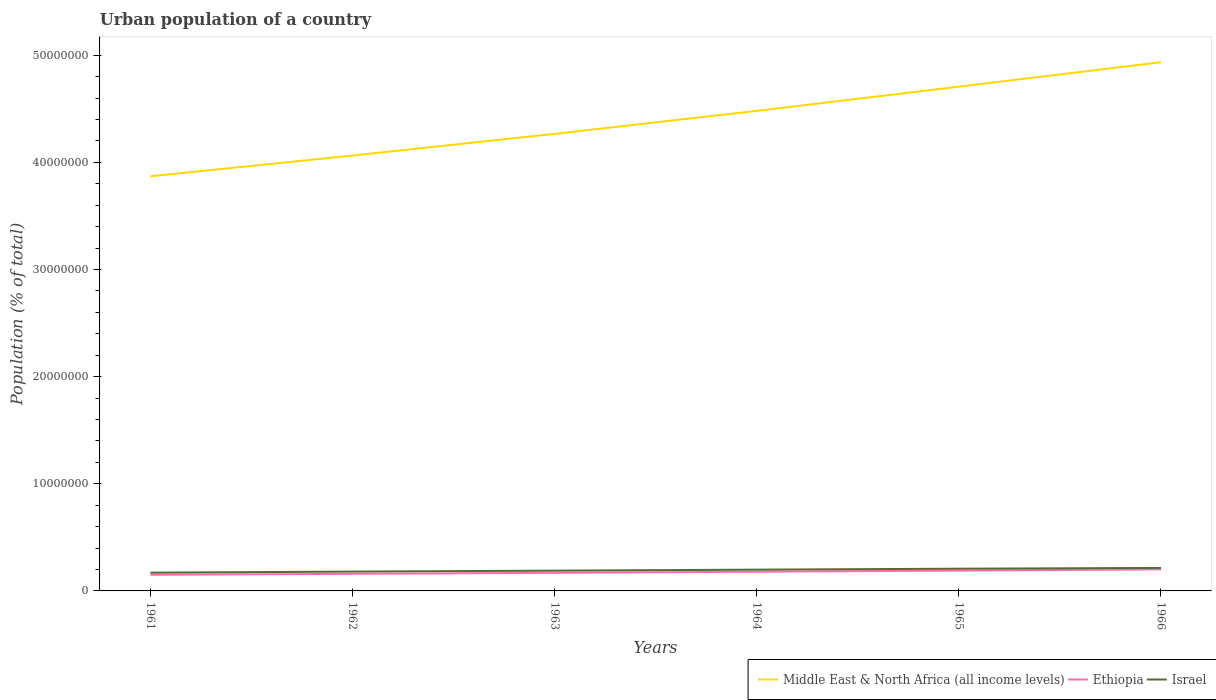How many different coloured lines are there?
Provide a short and direct response. 3. Does the line corresponding to Ethiopia intersect with the line corresponding to Middle East & North Africa (all income levels)?
Make the answer very short. No. Across all years, what is the maximum urban population in Israel?
Provide a short and direct response. 1.70e+06. What is the total urban population in Ethiopia in the graph?
Your answer should be very brief. -8.86e+04. What is the difference between the highest and the second highest urban population in Middle East & North Africa (all income levels)?
Provide a succinct answer. 1.07e+07. Are the values on the major ticks of Y-axis written in scientific E-notation?
Offer a very short reply. No. Does the graph contain any zero values?
Ensure brevity in your answer.  No. Does the graph contain grids?
Offer a very short reply. No. Where does the legend appear in the graph?
Your response must be concise. Bottom right. How many legend labels are there?
Your answer should be compact. 3. What is the title of the graph?
Make the answer very short. Urban population of a country. What is the label or title of the Y-axis?
Give a very brief answer. Population (% of total). What is the Population (% of total) in Middle East & North Africa (all income levels) in 1961?
Offer a very short reply. 3.87e+07. What is the Population (% of total) in Ethiopia in 1961?
Offer a terse response. 1.51e+06. What is the Population (% of total) in Israel in 1961?
Give a very brief answer. 1.70e+06. What is the Population (% of total) in Middle East & North Africa (all income levels) in 1962?
Provide a short and direct response. 4.06e+07. What is the Population (% of total) in Ethiopia in 1962?
Provide a short and direct response. 1.60e+06. What is the Population (% of total) in Israel in 1962?
Provide a short and direct response. 1.81e+06. What is the Population (% of total) of Middle East & North Africa (all income levels) in 1963?
Make the answer very short. 4.27e+07. What is the Population (% of total) in Ethiopia in 1963?
Keep it short and to the point. 1.69e+06. What is the Population (% of total) in Israel in 1963?
Provide a succinct answer. 1.89e+06. What is the Population (% of total) of Middle East & North Africa (all income levels) in 1964?
Give a very brief answer. 4.48e+07. What is the Population (% of total) in Ethiopia in 1964?
Ensure brevity in your answer.  1.79e+06. What is the Population (% of total) in Israel in 1964?
Offer a very short reply. 1.99e+06. What is the Population (% of total) in Middle East & North Africa (all income levels) in 1965?
Keep it short and to the point. 4.71e+07. What is the Population (% of total) in Ethiopia in 1965?
Keep it short and to the point. 1.90e+06. What is the Population (% of total) of Israel in 1965?
Offer a very short reply. 2.07e+06. What is the Population (% of total) of Middle East & North Africa (all income levels) in 1966?
Your answer should be compact. 4.94e+07. What is the Population (% of total) of Ethiopia in 1966?
Provide a succinct answer. 2.01e+06. What is the Population (% of total) of Israel in 1966?
Ensure brevity in your answer.  2.15e+06. Across all years, what is the maximum Population (% of total) of Middle East & North Africa (all income levels)?
Give a very brief answer. 4.94e+07. Across all years, what is the maximum Population (% of total) in Ethiopia?
Ensure brevity in your answer.  2.01e+06. Across all years, what is the maximum Population (% of total) of Israel?
Your response must be concise. 2.15e+06. Across all years, what is the minimum Population (% of total) in Middle East & North Africa (all income levels)?
Provide a succinct answer. 3.87e+07. Across all years, what is the minimum Population (% of total) in Ethiopia?
Make the answer very short. 1.51e+06. Across all years, what is the minimum Population (% of total) in Israel?
Give a very brief answer. 1.70e+06. What is the total Population (% of total) in Middle East & North Africa (all income levels) in the graph?
Your response must be concise. 2.63e+08. What is the total Population (% of total) in Ethiopia in the graph?
Your response must be concise. 1.05e+07. What is the total Population (% of total) of Israel in the graph?
Ensure brevity in your answer.  1.16e+07. What is the difference between the Population (% of total) in Middle East & North Africa (all income levels) in 1961 and that in 1962?
Provide a succinct answer. -1.94e+06. What is the difference between the Population (% of total) in Ethiopia in 1961 and that in 1962?
Your answer should be very brief. -8.86e+04. What is the difference between the Population (% of total) in Israel in 1961 and that in 1962?
Provide a short and direct response. -1.02e+05. What is the difference between the Population (% of total) in Middle East & North Africa (all income levels) in 1961 and that in 1963?
Offer a very short reply. -3.96e+06. What is the difference between the Population (% of total) of Ethiopia in 1961 and that in 1963?
Your response must be concise. -1.83e+05. What is the difference between the Population (% of total) of Israel in 1961 and that in 1963?
Offer a terse response. -1.87e+05. What is the difference between the Population (% of total) in Middle East & North Africa (all income levels) in 1961 and that in 1964?
Ensure brevity in your answer.  -6.11e+06. What is the difference between the Population (% of total) of Ethiopia in 1961 and that in 1964?
Your response must be concise. -2.84e+05. What is the difference between the Population (% of total) in Israel in 1961 and that in 1964?
Your response must be concise. -2.82e+05. What is the difference between the Population (% of total) of Middle East & North Africa (all income levels) in 1961 and that in 1965?
Provide a succinct answer. -8.37e+06. What is the difference between the Population (% of total) in Ethiopia in 1961 and that in 1965?
Ensure brevity in your answer.  -3.90e+05. What is the difference between the Population (% of total) of Israel in 1961 and that in 1965?
Provide a short and direct response. -3.71e+05. What is the difference between the Population (% of total) in Middle East & North Africa (all income levels) in 1961 and that in 1966?
Your response must be concise. -1.07e+07. What is the difference between the Population (% of total) of Ethiopia in 1961 and that in 1966?
Your answer should be very brief. -5.03e+05. What is the difference between the Population (% of total) of Israel in 1961 and that in 1966?
Ensure brevity in your answer.  -4.42e+05. What is the difference between the Population (% of total) in Middle East & North Africa (all income levels) in 1962 and that in 1963?
Your response must be concise. -2.03e+06. What is the difference between the Population (% of total) in Ethiopia in 1962 and that in 1963?
Your answer should be compact. -9.44e+04. What is the difference between the Population (% of total) of Israel in 1962 and that in 1963?
Provide a short and direct response. -8.55e+04. What is the difference between the Population (% of total) in Middle East & North Africa (all income levels) in 1962 and that in 1964?
Keep it short and to the point. -4.17e+06. What is the difference between the Population (% of total) in Ethiopia in 1962 and that in 1964?
Offer a terse response. -1.95e+05. What is the difference between the Population (% of total) of Israel in 1962 and that in 1964?
Your answer should be very brief. -1.80e+05. What is the difference between the Population (% of total) of Middle East & North Africa (all income levels) in 1962 and that in 1965?
Make the answer very short. -6.43e+06. What is the difference between the Population (% of total) in Ethiopia in 1962 and that in 1965?
Your answer should be very brief. -3.02e+05. What is the difference between the Population (% of total) in Israel in 1962 and that in 1965?
Ensure brevity in your answer.  -2.69e+05. What is the difference between the Population (% of total) in Middle East & North Africa (all income levels) in 1962 and that in 1966?
Ensure brevity in your answer.  -8.71e+06. What is the difference between the Population (% of total) in Ethiopia in 1962 and that in 1966?
Provide a succinct answer. -4.14e+05. What is the difference between the Population (% of total) of Israel in 1962 and that in 1966?
Offer a terse response. -3.40e+05. What is the difference between the Population (% of total) in Middle East & North Africa (all income levels) in 1963 and that in 1964?
Offer a terse response. -2.14e+06. What is the difference between the Population (% of total) of Ethiopia in 1963 and that in 1964?
Your answer should be very brief. -1.01e+05. What is the difference between the Population (% of total) in Israel in 1963 and that in 1964?
Offer a terse response. -9.44e+04. What is the difference between the Population (% of total) of Middle East & North Africa (all income levels) in 1963 and that in 1965?
Your response must be concise. -4.41e+06. What is the difference between the Population (% of total) of Ethiopia in 1963 and that in 1965?
Your answer should be very brief. -2.07e+05. What is the difference between the Population (% of total) in Israel in 1963 and that in 1965?
Provide a succinct answer. -1.83e+05. What is the difference between the Population (% of total) of Middle East & North Africa (all income levels) in 1963 and that in 1966?
Offer a terse response. -6.69e+06. What is the difference between the Population (% of total) of Ethiopia in 1963 and that in 1966?
Provide a succinct answer. -3.20e+05. What is the difference between the Population (% of total) in Israel in 1963 and that in 1966?
Offer a very short reply. -2.55e+05. What is the difference between the Population (% of total) in Middle East & North Africa (all income levels) in 1964 and that in 1965?
Ensure brevity in your answer.  -2.26e+06. What is the difference between the Population (% of total) in Ethiopia in 1964 and that in 1965?
Offer a terse response. -1.07e+05. What is the difference between the Population (% of total) of Israel in 1964 and that in 1965?
Make the answer very short. -8.88e+04. What is the difference between the Population (% of total) in Middle East & North Africa (all income levels) in 1964 and that in 1966?
Provide a succinct answer. -4.54e+06. What is the difference between the Population (% of total) in Ethiopia in 1964 and that in 1966?
Your response must be concise. -2.19e+05. What is the difference between the Population (% of total) in Israel in 1964 and that in 1966?
Your answer should be compact. -1.60e+05. What is the difference between the Population (% of total) of Middle East & North Africa (all income levels) in 1965 and that in 1966?
Provide a short and direct response. -2.28e+06. What is the difference between the Population (% of total) of Ethiopia in 1965 and that in 1966?
Make the answer very short. -1.12e+05. What is the difference between the Population (% of total) in Israel in 1965 and that in 1966?
Give a very brief answer. -7.16e+04. What is the difference between the Population (% of total) in Middle East & North Africa (all income levels) in 1961 and the Population (% of total) in Ethiopia in 1962?
Offer a very short reply. 3.71e+07. What is the difference between the Population (% of total) of Middle East & North Africa (all income levels) in 1961 and the Population (% of total) of Israel in 1962?
Offer a very short reply. 3.69e+07. What is the difference between the Population (% of total) of Ethiopia in 1961 and the Population (% of total) of Israel in 1962?
Your answer should be very brief. -2.98e+05. What is the difference between the Population (% of total) in Middle East & North Africa (all income levels) in 1961 and the Population (% of total) in Ethiopia in 1963?
Make the answer very short. 3.70e+07. What is the difference between the Population (% of total) of Middle East & North Africa (all income levels) in 1961 and the Population (% of total) of Israel in 1963?
Keep it short and to the point. 3.68e+07. What is the difference between the Population (% of total) in Ethiopia in 1961 and the Population (% of total) in Israel in 1963?
Provide a short and direct response. -3.84e+05. What is the difference between the Population (% of total) of Middle East & North Africa (all income levels) in 1961 and the Population (% of total) of Ethiopia in 1964?
Ensure brevity in your answer.  3.69e+07. What is the difference between the Population (% of total) of Middle East & North Africa (all income levels) in 1961 and the Population (% of total) of Israel in 1964?
Provide a succinct answer. 3.67e+07. What is the difference between the Population (% of total) of Ethiopia in 1961 and the Population (% of total) of Israel in 1964?
Provide a succinct answer. -4.78e+05. What is the difference between the Population (% of total) in Middle East & North Africa (all income levels) in 1961 and the Population (% of total) in Ethiopia in 1965?
Ensure brevity in your answer.  3.68e+07. What is the difference between the Population (% of total) of Middle East & North Africa (all income levels) in 1961 and the Population (% of total) of Israel in 1965?
Provide a succinct answer. 3.66e+07. What is the difference between the Population (% of total) of Ethiopia in 1961 and the Population (% of total) of Israel in 1965?
Your answer should be compact. -5.67e+05. What is the difference between the Population (% of total) of Middle East & North Africa (all income levels) in 1961 and the Population (% of total) of Ethiopia in 1966?
Provide a short and direct response. 3.67e+07. What is the difference between the Population (% of total) of Middle East & North Africa (all income levels) in 1961 and the Population (% of total) of Israel in 1966?
Make the answer very short. 3.66e+07. What is the difference between the Population (% of total) in Ethiopia in 1961 and the Population (% of total) in Israel in 1966?
Your response must be concise. -6.38e+05. What is the difference between the Population (% of total) in Middle East & North Africa (all income levels) in 1962 and the Population (% of total) in Ethiopia in 1963?
Your response must be concise. 3.90e+07. What is the difference between the Population (% of total) in Middle East & North Africa (all income levels) in 1962 and the Population (% of total) in Israel in 1963?
Provide a succinct answer. 3.88e+07. What is the difference between the Population (% of total) of Ethiopia in 1962 and the Population (% of total) of Israel in 1963?
Ensure brevity in your answer.  -2.95e+05. What is the difference between the Population (% of total) of Middle East & North Africa (all income levels) in 1962 and the Population (% of total) of Ethiopia in 1964?
Provide a short and direct response. 3.89e+07. What is the difference between the Population (% of total) in Middle East & North Africa (all income levels) in 1962 and the Population (% of total) in Israel in 1964?
Offer a terse response. 3.87e+07. What is the difference between the Population (% of total) of Ethiopia in 1962 and the Population (% of total) of Israel in 1964?
Make the answer very short. -3.90e+05. What is the difference between the Population (% of total) in Middle East & North Africa (all income levels) in 1962 and the Population (% of total) in Ethiopia in 1965?
Your response must be concise. 3.87e+07. What is the difference between the Population (% of total) of Middle East & North Africa (all income levels) in 1962 and the Population (% of total) of Israel in 1965?
Keep it short and to the point. 3.86e+07. What is the difference between the Population (% of total) in Ethiopia in 1962 and the Population (% of total) in Israel in 1965?
Offer a very short reply. -4.78e+05. What is the difference between the Population (% of total) of Middle East & North Africa (all income levels) in 1962 and the Population (% of total) of Ethiopia in 1966?
Your answer should be compact. 3.86e+07. What is the difference between the Population (% of total) in Middle East & North Africa (all income levels) in 1962 and the Population (% of total) in Israel in 1966?
Make the answer very short. 3.85e+07. What is the difference between the Population (% of total) of Ethiopia in 1962 and the Population (% of total) of Israel in 1966?
Your answer should be very brief. -5.50e+05. What is the difference between the Population (% of total) in Middle East & North Africa (all income levels) in 1963 and the Population (% of total) in Ethiopia in 1964?
Offer a terse response. 4.09e+07. What is the difference between the Population (% of total) of Middle East & North Africa (all income levels) in 1963 and the Population (% of total) of Israel in 1964?
Your answer should be compact. 4.07e+07. What is the difference between the Population (% of total) in Ethiopia in 1963 and the Population (% of total) in Israel in 1964?
Your answer should be compact. -2.95e+05. What is the difference between the Population (% of total) of Middle East & North Africa (all income levels) in 1963 and the Population (% of total) of Ethiopia in 1965?
Give a very brief answer. 4.08e+07. What is the difference between the Population (% of total) in Middle East & North Africa (all income levels) in 1963 and the Population (% of total) in Israel in 1965?
Ensure brevity in your answer.  4.06e+07. What is the difference between the Population (% of total) in Ethiopia in 1963 and the Population (% of total) in Israel in 1965?
Ensure brevity in your answer.  -3.84e+05. What is the difference between the Population (% of total) of Middle East & North Africa (all income levels) in 1963 and the Population (% of total) of Ethiopia in 1966?
Give a very brief answer. 4.07e+07. What is the difference between the Population (% of total) of Middle East & North Africa (all income levels) in 1963 and the Population (% of total) of Israel in 1966?
Keep it short and to the point. 4.05e+07. What is the difference between the Population (% of total) in Ethiopia in 1963 and the Population (% of total) in Israel in 1966?
Make the answer very short. -4.55e+05. What is the difference between the Population (% of total) of Middle East & North Africa (all income levels) in 1964 and the Population (% of total) of Ethiopia in 1965?
Your response must be concise. 4.29e+07. What is the difference between the Population (% of total) of Middle East & North Africa (all income levels) in 1964 and the Population (% of total) of Israel in 1965?
Offer a very short reply. 4.27e+07. What is the difference between the Population (% of total) in Ethiopia in 1964 and the Population (% of total) in Israel in 1965?
Make the answer very short. -2.83e+05. What is the difference between the Population (% of total) of Middle East & North Africa (all income levels) in 1964 and the Population (% of total) of Ethiopia in 1966?
Offer a terse response. 4.28e+07. What is the difference between the Population (% of total) of Middle East & North Africa (all income levels) in 1964 and the Population (% of total) of Israel in 1966?
Offer a very short reply. 4.27e+07. What is the difference between the Population (% of total) in Ethiopia in 1964 and the Population (% of total) in Israel in 1966?
Offer a terse response. -3.55e+05. What is the difference between the Population (% of total) of Middle East & North Africa (all income levels) in 1965 and the Population (% of total) of Ethiopia in 1966?
Ensure brevity in your answer.  4.51e+07. What is the difference between the Population (% of total) of Middle East & North Africa (all income levels) in 1965 and the Population (% of total) of Israel in 1966?
Your response must be concise. 4.49e+07. What is the difference between the Population (% of total) of Ethiopia in 1965 and the Population (% of total) of Israel in 1966?
Ensure brevity in your answer.  -2.48e+05. What is the average Population (% of total) in Middle East & North Africa (all income levels) per year?
Your response must be concise. 4.39e+07. What is the average Population (% of total) in Ethiopia per year?
Give a very brief answer. 1.75e+06. What is the average Population (% of total) in Israel per year?
Make the answer very short. 1.93e+06. In the year 1961, what is the difference between the Population (% of total) of Middle East & North Africa (all income levels) and Population (% of total) of Ethiopia?
Keep it short and to the point. 3.72e+07. In the year 1961, what is the difference between the Population (% of total) of Middle East & North Africa (all income levels) and Population (% of total) of Israel?
Your response must be concise. 3.70e+07. In the year 1961, what is the difference between the Population (% of total) in Ethiopia and Population (% of total) in Israel?
Your answer should be compact. -1.96e+05. In the year 1962, what is the difference between the Population (% of total) in Middle East & North Africa (all income levels) and Population (% of total) in Ethiopia?
Offer a terse response. 3.90e+07. In the year 1962, what is the difference between the Population (% of total) in Middle East & North Africa (all income levels) and Population (% of total) in Israel?
Give a very brief answer. 3.88e+07. In the year 1962, what is the difference between the Population (% of total) in Ethiopia and Population (% of total) in Israel?
Offer a terse response. -2.10e+05. In the year 1963, what is the difference between the Population (% of total) in Middle East & North Africa (all income levels) and Population (% of total) in Ethiopia?
Provide a succinct answer. 4.10e+07. In the year 1963, what is the difference between the Population (% of total) in Middle East & North Africa (all income levels) and Population (% of total) in Israel?
Provide a succinct answer. 4.08e+07. In the year 1963, what is the difference between the Population (% of total) of Ethiopia and Population (% of total) of Israel?
Your answer should be very brief. -2.01e+05. In the year 1964, what is the difference between the Population (% of total) of Middle East & North Africa (all income levels) and Population (% of total) of Ethiopia?
Keep it short and to the point. 4.30e+07. In the year 1964, what is the difference between the Population (% of total) in Middle East & North Africa (all income levels) and Population (% of total) in Israel?
Give a very brief answer. 4.28e+07. In the year 1964, what is the difference between the Population (% of total) of Ethiopia and Population (% of total) of Israel?
Offer a very short reply. -1.95e+05. In the year 1965, what is the difference between the Population (% of total) of Middle East & North Africa (all income levels) and Population (% of total) of Ethiopia?
Offer a terse response. 4.52e+07. In the year 1965, what is the difference between the Population (% of total) in Middle East & North Africa (all income levels) and Population (% of total) in Israel?
Offer a very short reply. 4.50e+07. In the year 1965, what is the difference between the Population (% of total) in Ethiopia and Population (% of total) in Israel?
Provide a short and direct response. -1.77e+05. In the year 1966, what is the difference between the Population (% of total) in Middle East & North Africa (all income levels) and Population (% of total) in Ethiopia?
Your answer should be very brief. 4.73e+07. In the year 1966, what is the difference between the Population (% of total) in Middle East & North Africa (all income levels) and Population (% of total) in Israel?
Provide a short and direct response. 4.72e+07. In the year 1966, what is the difference between the Population (% of total) in Ethiopia and Population (% of total) in Israel?
Your answer should be compact. -1.36e+05. What is the ratio of the Population (% of total) of Middle East & North Africa (all income levels) in 1961 to that in 1962?
Ensure brevity in your answer.  0.95. What is the ratio of the Population (% of total) of Ethiopia in 1961 to that in 1962?
Keep it short and to the point. 0.94. What is the ratio of the Population (% of total) of Israel in 1961 to that in 1962?
Offer a terse response. 0.94. What is the ratio of the Population (% of total) in Middle East & North Africa (all income levels) in 1961 to that in 1963?
Keep it short and to the point. 0.91. What is the ratio of the Population (% of total) of Ethiopia in 1961 to that in 1963?
Make the answer very short. 0.89. What is the ratio of the Population (% of total) of Israel in 1961 to that in 1963?
Your answer should be compact. 0.9. What is the ratio of the Population (% of total) of Middle East & North Africa (all income levels) in 1961 to that in 1964?
Your answer should be very brief. 0.86. What is the ratio of the Population (% of total) of Ethiopia in 1961 to that in 1964?
Make the answer very short. 0.84. What is the ratio of the Population (% of total) in Israel in 1961 to that in 1964?
Offer a very short reply. 0.86. What is the ratio of the Population (% of total) in Middle East & North Africa (all income levels) in 1961 to that in 1965?
Provide a succinct answer. 0.82. What is the ratio of the Population (% of total) in Ethiopia in 1961 to that in 1965?
Your response must be concise. 0.79. What is the ratio of the Population (% of total) of Israel in 1961 to that in 1965?
Offer a terse response. 0.82. What is the ratio of the Population (% of total) in Middle East & North Africa (all income levels) in 1961 to that in 1966?
Offer a very short reply. 0.78. What is the ratio of the Population (% of total) in Ethiopia in 1961 to that in 1966?
Keep it short and to the point. 0.75. What is the ratio of the Population (% of total) in Israel in 1961 to that in 1966?
Your response must be concise. 0.79. What is the ratio of the Population (% of total) in Middle East & North Africa (all income levels) in 1962 to that in 1963?
Make the answer very short. 0.95. What is the ratio of the Population (% of total) in Ethiopia in 1962 to that in 1963?
Keep it short and to the point. 0.94. What is the ratio of the Population (% of total) in Israel in 1962 to that in 1963?
Keep it short and to the point. 0.95. What is the ratio of the Population (% of total) in Middle East & North Africa (all income levels) in 1962 to that in 1964?
Provide a succinct answer. 0.91. What is the ratio of the Population (% of total) in Ethiopia in 1962 to that in 1964?
Ensure brevity in your answer.  0.89. What is the ratio of the Population (% of total) of Israel in 1962 to that in 1964?
Make the answer very short. 0.91. What is the ratio of the Population (% of total) of Middle East & North Africa (all income levels) in 1962 to that in 1965?
Give a very brief answer. 0.86. What is the ratio of the Population (% of total) of Ethiopia in 1962 to that in 1965?
Your answer should be compact. 0.84. What is the ratio of the Population (% of total) in Israel in 1962 to that in 1965?
Your answer should be very brief. 0.87. What is the ratio of the Population (% of total) in Middle East & North Africa (all income levels) in 1962 to that in 1966?
Offer a very short reply. 0.82. What is the ratio of the Population (% of total) of Ethiopia in 1962 to that in 1966?
Your answer should be compact. 0.79. What is the ratio of the Population (% of total) in Israel in 1962 to that in 1966?
Your answer should be very brief. 0.84. What is the ratio of the Population (% of total) in Middle East & North Africa (all income levels) in 1963 to that in 1964?
Keep it short and to the point. 0.95. What is the ratio of the Population (% of total) of Ethiopia in 1963 to that in 1964?
Keep it short and to the point. 0.94. What is the ratio of the Population (% of total) of Israel in 1963 to that in 1964?
Provide a succinct answer. 0.95. What is the ratio of the Population (% of total) of Middle East & North Africa (all income levels) in 1963 to that in 1965?
Give a very brief answer. 0.91. What is the ratio of the Population (% of total) of Ethiopia in 1963 to that in 1965?
Keep it short and to the point. 0.89. What is the ratio of the Population (% of total) of Israel in 1963 to that in 1965?
Give a very brief answer. 0.91. What is the ratio of the Population (% of total) in Middle East & North Africa (all income levels) in 1963 to that in 1966?
Keep it short and to the point. 0.86. What is the ratio of the Population (% of total) in Ethiopia in 1963 to that in 1966?
Make the answer very short. 0.84. What is the ratio of the Population (% of total) of Israel in 1963 to that in 1966?
Your response must be concise. 0.88. What is the ratio of the Population (% of total) of Middle East & North Africa (all income levels) in 1964 to that in 1965?
Make the answer very short. 0.95. What is the ratio of the Population (% of total) of Ethiopia in 1964 to that in 1965?
Your answer should be very brief. 0.94. What is the ratio of the Population (% of total) of Israel in 1964 to that in 1965?
Your answer should be compact. 0.96. What is the ratio of the Population (% of total) in Middle East & North Africa (all income levels) in 1964 to that in 1966?
Provide a succinct answer. 0.91. What is the ratio of the Population (% of total) of Ethiopia in 1964 to that in 1966?
Offer a very short reply. 0.89. What is the ratio of the Population (% of total) of Israel in 1964 to that in 1966?
Your answer should be very brief. 0.93. What is the ratio of the Population (% of total) in Middle East & North Africa (all income levels) in 1965 to that in 1966?
Offer a very short reply. 0.95. What is the ratio of the Population (% of total) of Ethiopia in 1965 to that in 1966?
Offer a terse response. 0.94. What is the ratio of the Population (% of total) of Israel in 1965 to that in 1966?
Your answer should be very brief. 0.97. What is the difference between the highest and the second highest Population (% of total) of Middle East & North Africa (all income levels)?
Offer a terse response. 2.28e+06. What is the difference between the highest and the second highest Population (% of total) of Ethiopia?
Make the answer very short. 1.12e+05. What is the difference between the highest and the second highest Population (% of total) in Israel?
Your response must be concise. 7.16e+04. What is the difference between the highest and the lowest Population (% of total) in Middle East & North Africa (all income levels)?
Your answer should be very brief. 1.07e+07. What is the difference between the highest and the lowest Population (% of total) of Ethiopia?
Your response must be concise. 5.03e+05. What is the difference between the highest and the lowest Population (% of total) in Israel?
Your response must be concise. 4.42e+05. 